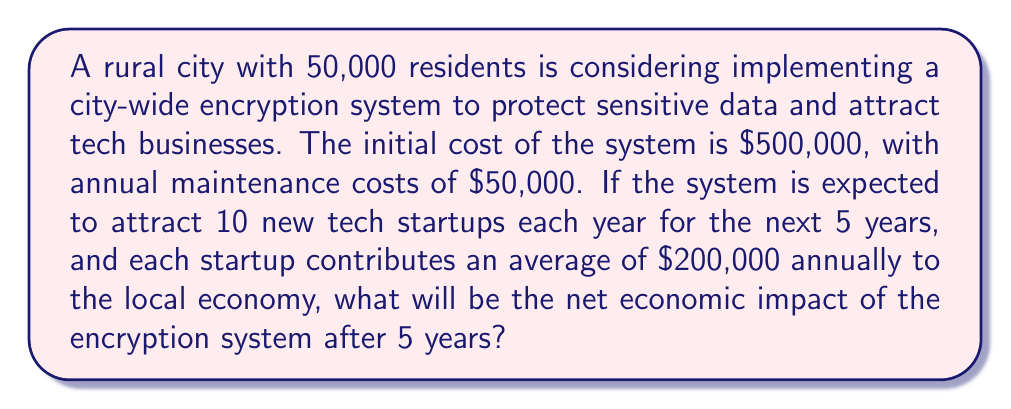Can you solve this math problem? Let's break this down step-by-step:

1) Calculate the total cost of the encryption system over 5 years:
   Initial cost: $500,000
   Annual maintenance: $50,000 × 5 years = $250,000
   Total cost: $500,000 + $250,000 = $750,000

2) Calculate the economic contribution of new startups:
   Number of startups per year: 10
   Annual contribution per startup: $200,000
   Number of years: 5

   We need to account for the cumulative effect of startups over the years:
   Year 1: 10 startups × $200,000 = $2,000,000
   Year 2: 20 startups × $200,000 = $4,000,000
   Year 3: 30 startups × $200,000 = $6,000,000
   Year 4: 40 startups × $200,000 = $8,000,000
   Year 5: 50 startups × $200,000 = $10,000,000

3) Calculate the total economic contribution:
   $2,000,000 + $4,000,000 + $6,000,000 + $8,000,000 + $10,000,000 = $30,000,000

4) Calculate the net economic impact:
   Net impact = Total economic contribution - Total cost
   $$30,000,000 - 750,000 = $29,250,000$$
Answer: $29,250,000 